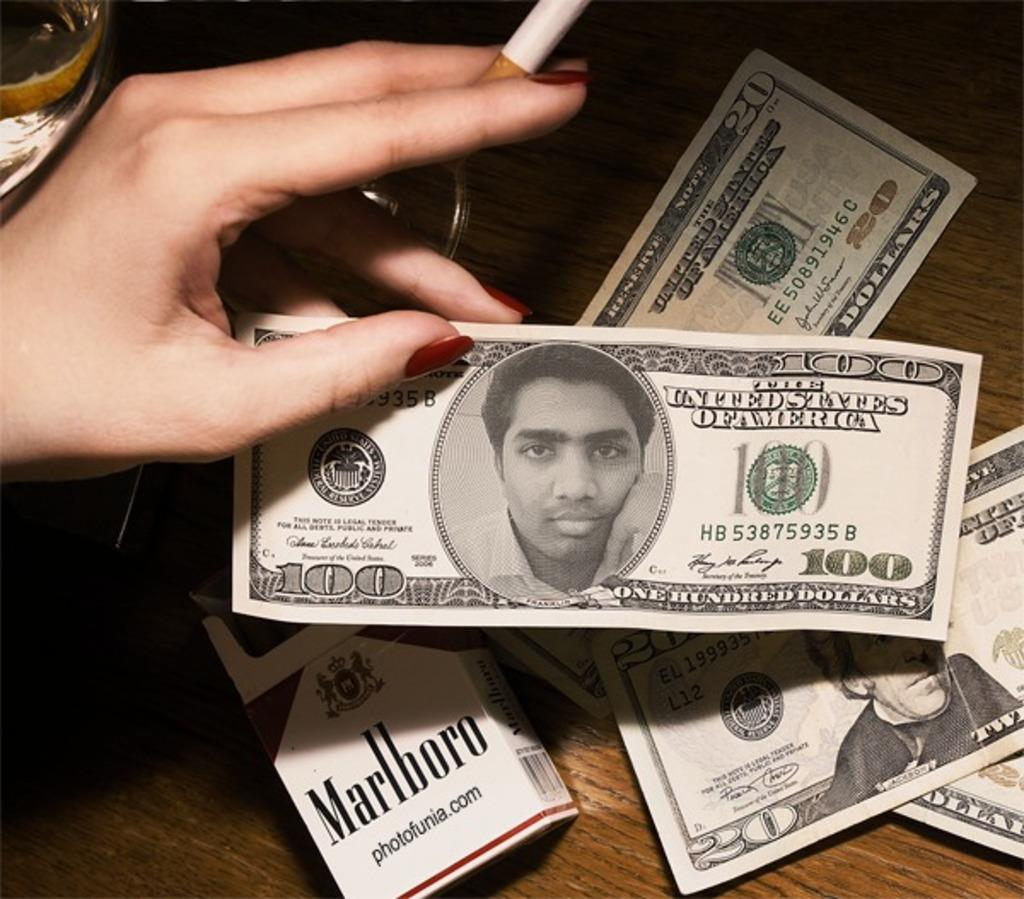<image>
Give a short and clear explanation of the subsequent image. A personal picture has replaced a portrait on a one hundred dollar bill. 